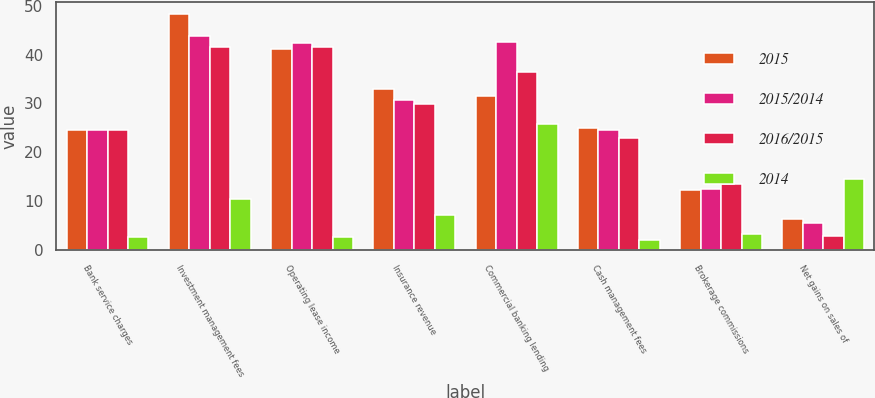Convert chart to OTSL. <chart><loc_0><loc_0><loc_500><loc_500><stacked_bar_chart><ecel><fcel>Bank service charges<fcel>Investment management fees<fcel>Operating lease income<fcel>Insurance revenue<fcel>Commercial banking lending<fcel>Cash management fees<fcel>Brokerage commissions<fcel>Net gains on sales of<nl><fcel>2015<fcel>24.5<fcel>48.3<fcel>41.2<fcel>32.9<fcel>31.6<fcel>25<fcel>12.2<fcel>6.3<nl><fcel>2015/2014<fcel>24.5<fcel>43.7<fcel>42.3<fcel>30.7<fcel>42.6<fcel>24.5<fcel>12.6<fcel>5.5<nl><fcel>2016/2015<fcel>24.5<fcel>41.6<fcel>41.6<fcel>29.9<fcel>36.4<fcel>22.9<fcel>13.6<fcel>2.9<nl><fcel>2014<fcel>2.7<fcel>10.5<fcel>2.6<fcel>7.2<fcel>25.8<fcel>2<fcel>3.2<fcel>14.5<nl></chart> 